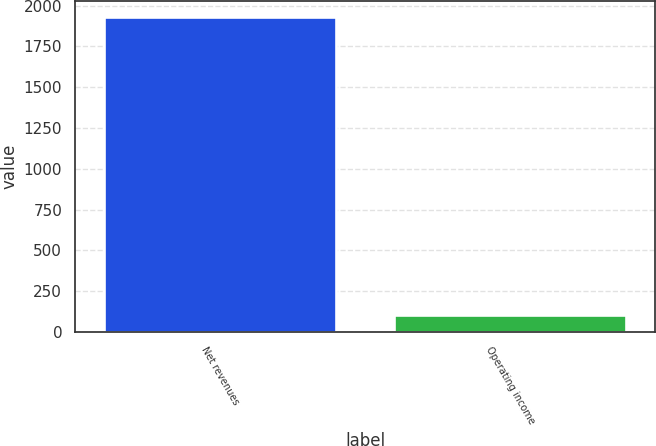Convert chart to OTSL. <chart><loc_0><loc_0><loc_500><loc_500><bar_chart><fcel>Net revenues<fcel>Operating income<nl><fcel>1930<fcel>102<nl></chart> 